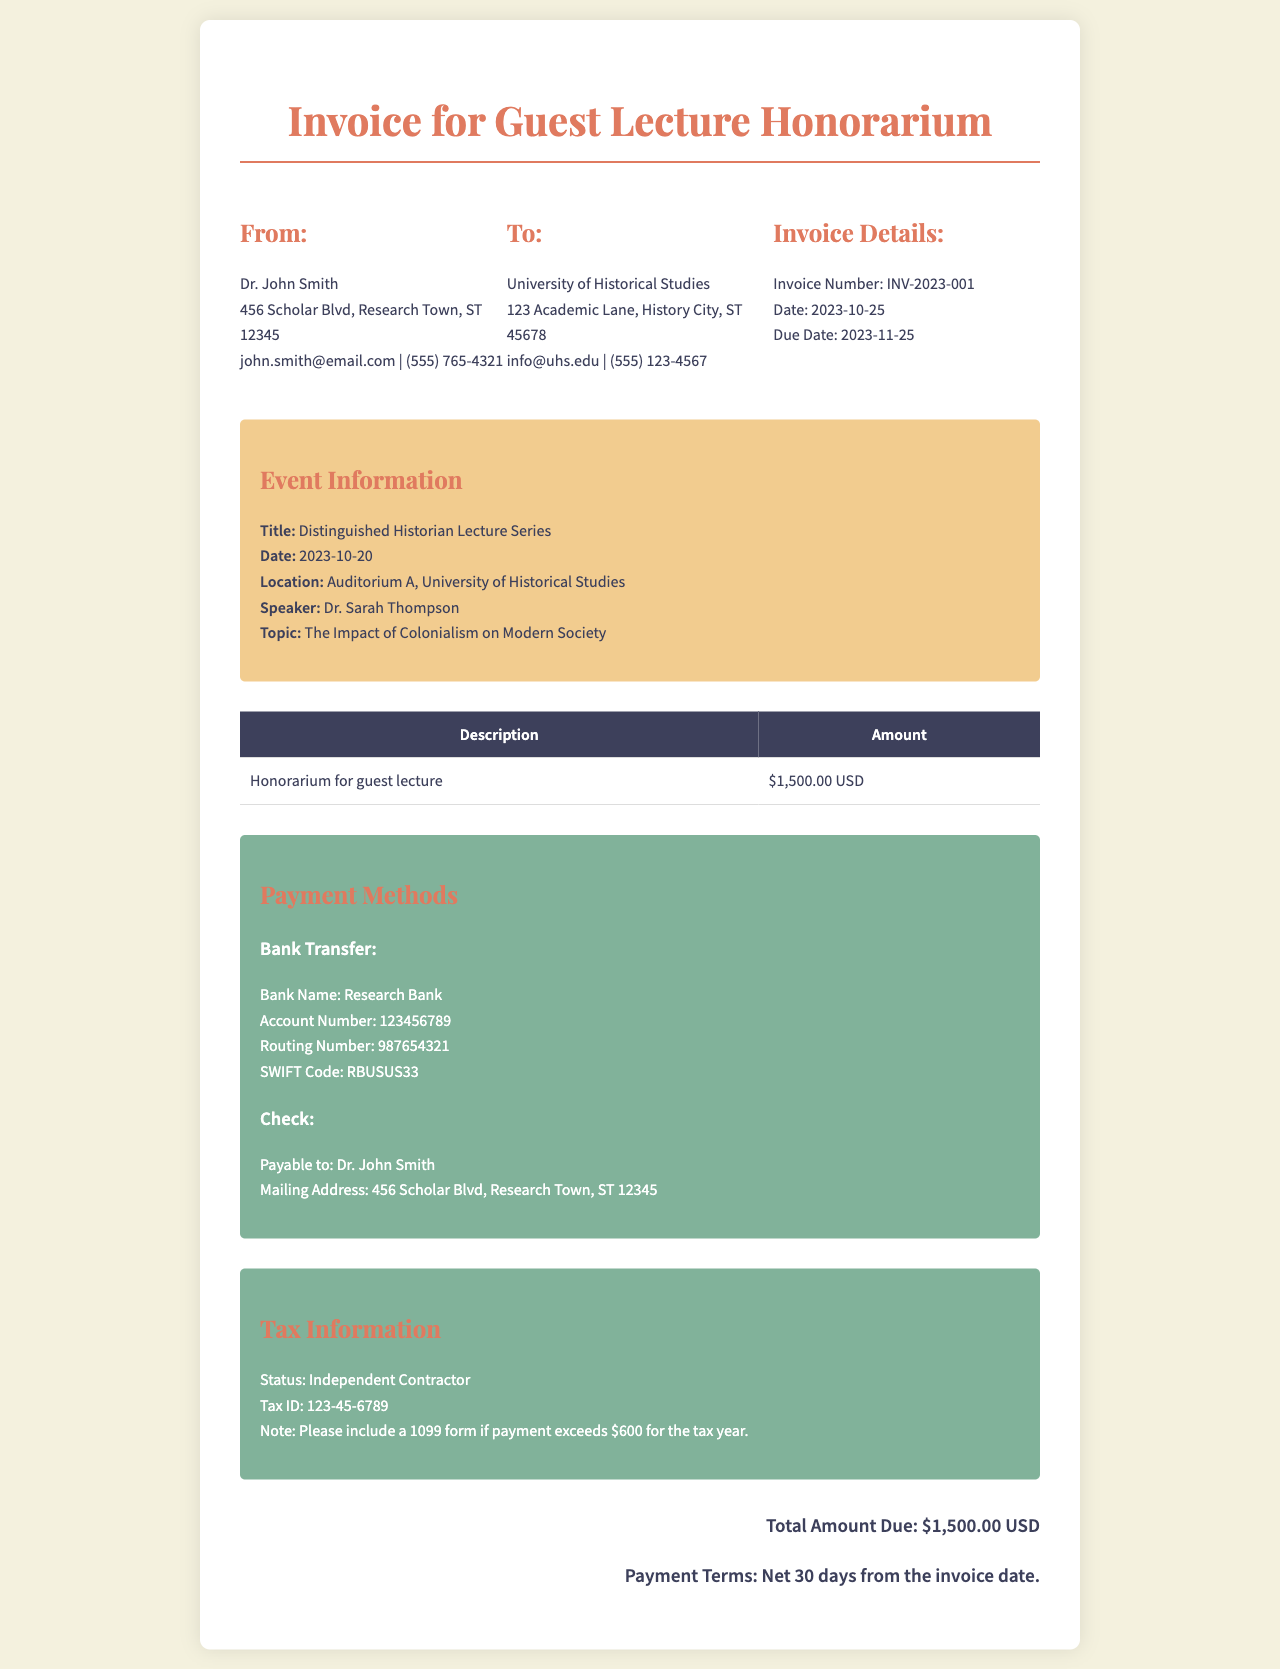What is the invoice number? The invoice number is specified in the document and is clearly indicated under the Invoice Details section.
Answer: INV-2023-001 What is the total amount due? The total amount due is mentioned in the summary section and reflects the total payment required for the service provided.
Answer: $1,500.00 USD What is the speaker's name? The speaker's name is mentioned in the event details section of the document.
Answer: Dr. Sarah Thompson What is the payment method for a check? The payment method for a check is detailed in the payment methods section, specifying who the check should be payable to.
Answer: Dr. John Smith What is the due date for payment? The due date is explicitly stated in the Invoice Details section of the document.
Answer: 2023-11-25 What is the tax status of the speaker? The speaker's tax status is outlined in the tax information section.
Answer: Independent Contractor What is the title of the event? The title of the event is specified in the event details section.
Answer: Distinguished Historian Lecture Series What is the mailing address for the check? The mailing address for sending a check is included in the payment methods area of the document.
Answer: 456 Scholar Blvd, Research Town, ST 12345 What is the SWIFT Code for bank transfer? The SWIFT Code for the bank transfer is detailed in the payment methods section.
Answer: RBUSUS33 